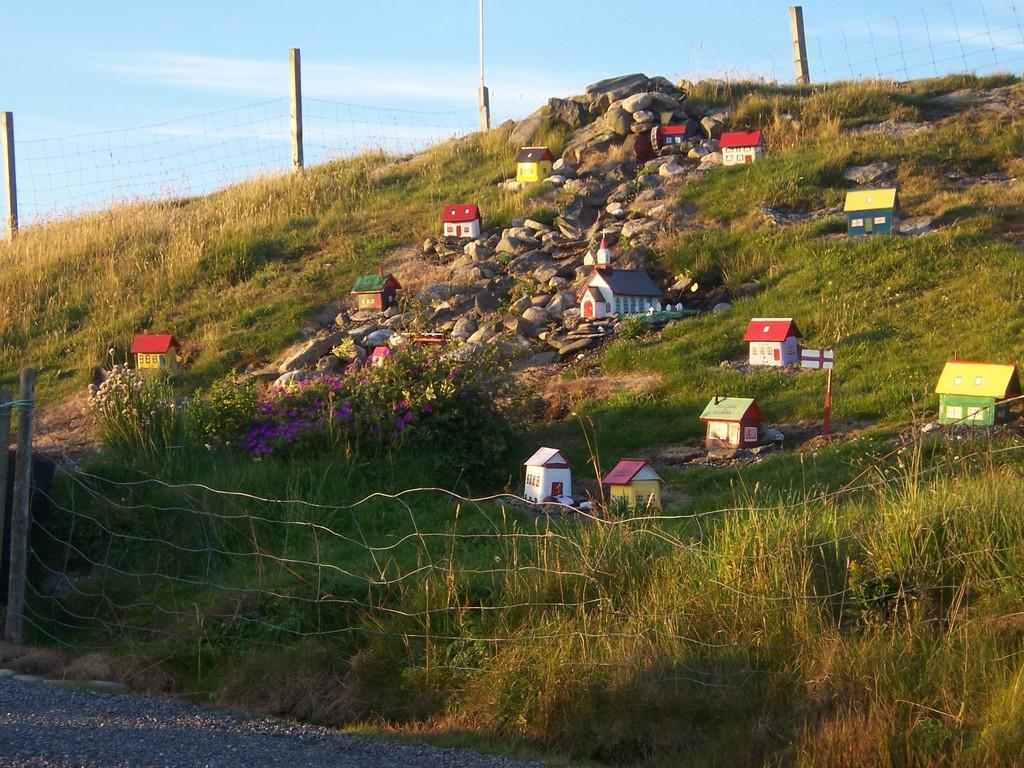How would you summarize this image in a sentence or two? In this image we can see depiction of houses, grass, stones. There is fencing. At the bottom of the image there is road. In the background of the image there is sky. 